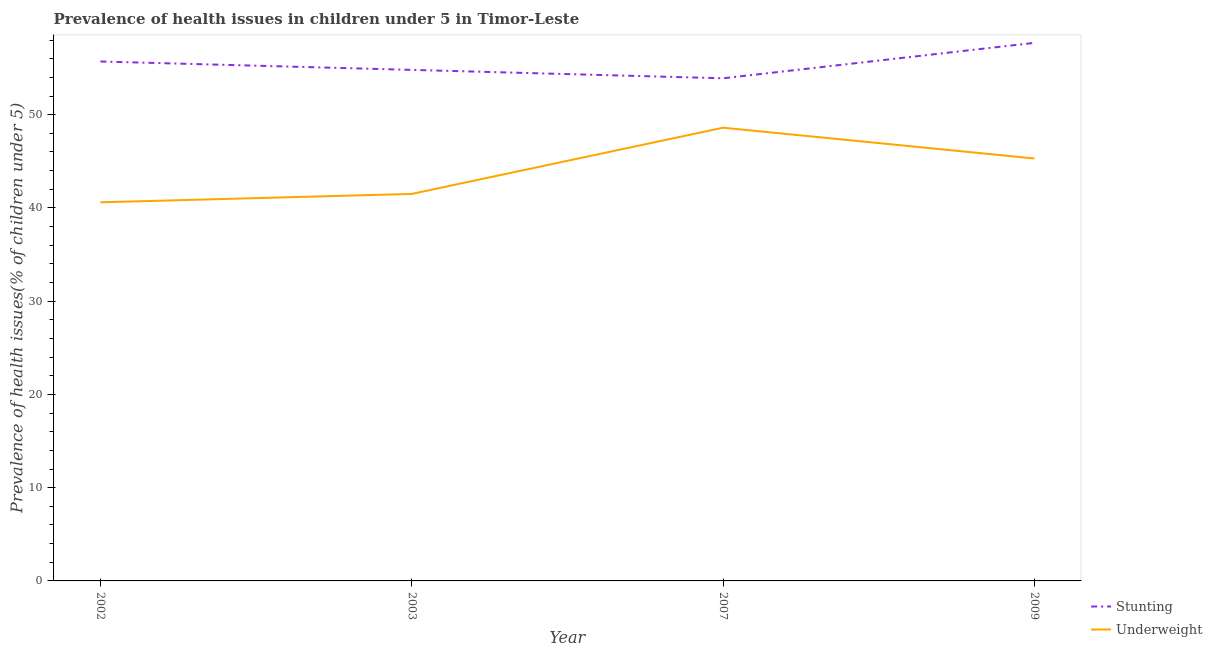How many different coloured lines are there?
Make the answer very short. 2. Is the number of lines equal to the number of legend labels?
Offer a very short reply. Yes. What is the percentage of underweight children in 2009?
Your answer should be very brief. 45.3. Across all years, what is the maximum percentage of underweight children?
Your answer should be compact. 48.6. Across all years, what is the minimum percentage of underweight children?
Offer a terse response. 40.6. What is the total percentage of underweight children in the graph?
Offer a terse response. 176. What is the difference between the percentage of underweight children in 2002 and that in 2003?
Provide a short and direct response. -0.9. What is the difference between the percentage of underweight children in 2007 and the percentage of stunted children in 2003?
Provide a succinct answer. -6.2. What is the average percentage of stunted children per year?
Provide a succinct answer. 55.53. In the year 2003, what is the difference between the percentage of underweight children and percentage of stunted children?
Your answer should be compact. -13.3. What is the ratio of the percentage of underweight children in 2002 to that in 2009?
Offer a very short reply. 0.9. Is the percentage of stunted children in 2002 less than that in 2003?
Your answer should be very brief. No. Is the difference between the percentage of underweight children in 2003 and 2007 greater than the difference between the percentage of stunted children in 2003 and 2007?
Ensure brevity in your answer.  No. In how many years, is the percentage of underweight children greater than the average percentage of underweight children taken over all years?
Provide a short and direct response. 2. Does the percentage of underweight children monotonically increase over the years?
Your answer should be very brief. No. Is the percentage of stunted children strictly less than the percentage of underweight children over the years?
Your response must be concise. No. How many lines are there?
Provide a succinct answer. 2. How many years are there in the graph?
Give a very brief answer. 4. Are the values on the major ticks of Y-axis written in scientific E-notation?
Provide a succinct answer. No. Does the graph contain any zero values?
Your answer should be very brief. No. Where does the legend appear in the graph?
Give a very brief answer. Bottom right. What is the title of the graph?
Your response must be concise. Prevalence of health issues in children under 5 in Timor-Leste. What is the label or title of the X-axis?
Offer a very short reply. Year. What is the label or title of the Y-axis?
Give a very brief answer. Prevalence of health issues(% of children under 5). What is the Prevalence of health issues(% of children under 5) in Stunting in 2002?
Your answer should be compact. 55.7. What is the Prevalence of health issues(% of children under 5) in Underweight in 2002?
Provide a succinct answer. 40.6. What is the Prevalence of health issues(% of children under 5) of Stunting in 2003?
Your response must be concise. 54.8. What is the Prevalence of health issues(% of children under 5) of Underweight in 2003?
Provide a short and direct response. 41.5. What is the Prevalence of health issues(% of children under 5) of Stunting in 2007?
Provide a succinct answer. 53.9. What is the Prevalence of health issues(% of children under 5) in Underweight in 2007?
Offer a terse response. 48.6. What is the Prevalence of health issues(% of children under 5) in Stunting in 2009?
Make the answer very short. 57.7. What is the Prevalence of health issues(% of children under 5) in Underweight in 2009?
Your answer should be very brief. 45.3. Across all years, what is the maximum Prevalence of health issues(% of children under 5) of Stunting?
Offer a terse response. 57.7. Across all years, what is the maximum Prevalence of health issues(% of children under 5) in Underweight?
Offer a terse response. 48.6. Across all years, what is the minimum Prevalence of health issues(% of children under 5) of Stunting?
Provide a succinct answer. 53.9. Across all years, what is the minimum Prevalence of health issues(% of children under 5) in Underweight?
Your answer should be compact. 40.6. What is the total Prevalence of health issues(% of children under 5) in Stunting in the graph?
Keep it short and to the point. 222.1. What is the total Prevalence of health issues(% of children under 5) of Underweight in the graph?
Ensure brevity in your answer.  176. What is the difference between the Prevalence of health issues(% of children under 5) in Underweight in 2002 and that in 2003?
Ensure brevity in your answer.  -0.9. What is the difference between the Prevalence of health issues(% of children under 5) in Stunting in 2002 and that in 2007?
Your answer should be compact. 1.8. What is the difference between the Prevalence of health issues(% of children under 5) of Underweight in 2002 and that in 2007?
Provide a succinct answer. -8. What is the difference between the Prevalence of health issues(% of children under 5) in Stunting in 2002 and that in 2009?
Provide a short and direct response. -2. What is the difference between the Prevalence of health issues(% of children under 5) in Stunting in 2007 and that in 2009?
Your response must be concise. -3.8. What is the difference between the Prevalence of health issues(% of children under 5) of Stunting in 2002 and the Prevalence of health issues(% of children under 5) of Underweight in 2007?
Your response must be concise. 7.1. What is the difference between the Prevalence of health issues(% of children under 5) of Stunting in 2003 and the Prevalence of health issues(% of children under 5) of Underweight in 2009?
Provide a short and direct response. 9.5. What is the average Prevalence of health issues(% of children under 5) in Stunting per year?
Keep it short and to the point. 55.52. In the year 2003, what is the difference between the Prevalence of health issues(% of children under 5) in Stunting and Prevalence of health issues(% of children under 5) in Underweight?
Offer a terse response. 13.3. In the year 2009, what is the difference between the Prevalence of health issues(% of children under 5) of Stunting and Prevalence of health issues(% of children under 5) of Underweight?
Give a very brief answer. 12.4. What is the ratio of the Prevalence of health issues(% of children under 5) in Stunting in 2002 to that in 2003?
Your response must be concise. 1.02. What is the ratio of the Prevalence of health issues(% of children under 5) in Underweight in 2002 to that in 2003?
Your answer should be very brief. 0.98. What is the ratio of the Prevalence of health issues(% of children under 5) of Stunting in 2002 to that in 2007?
Your response must be concise. 1.03. What is the ratio of the Prevalence of health issues(% of children under 5) in Underweight in 2002 to that in 2007?
Your answer should be compact. 0.84. What is the ratio of the Prevalence of health issues(% of children under 5) in Stunting in 2002 to that in 2009?
Make the answer very short. 0.97. What is the ratio of the Prevalence of health issues(% of children under 5) in Underweight in 2002 to that in 2009?
Offer a very short reply. 0.9. What is the ratio of the Prevalence of health issues(% of children under 5) of Stunting in 2003 to that in 2007?
Make the answer very short. 1.02. What is the ratio of the Prevalence of health issues(% of children under 5) in Underweight in 2003 to that in 2007?
Provide a short and direct response. 0.85. What is the ratio of the Prevalence of health issues(% of children under 5) in Stunting in 2003 to that in 2009?
Keep it short and to the point. 0.95. What is the ratio of the Prevalence of health issues(% of children under 5) of Underweight in 2003 to that in 2009?
Provide a succinct answer. 0.92. What is the ratio of the Prevalence of health issues(% of children under 5) of Stunting in 2007 to that in 2009?
Your response must be concise. 0.93. What is the ratio of the Prevalence of health issues(% of children under 5) of Underweight in 2007 to that in 2009?
Provide a succinct answer. 1.07. What is the difference between the highest and the second highest Prevalence of health issues(% of children under 5) of Stunting?
Give a very brief answer. 2. What is the difference between the highest and the second highest Prevalence of health issues(% of children under 5) in Underweight?
Your response must be concise. 3.3. 